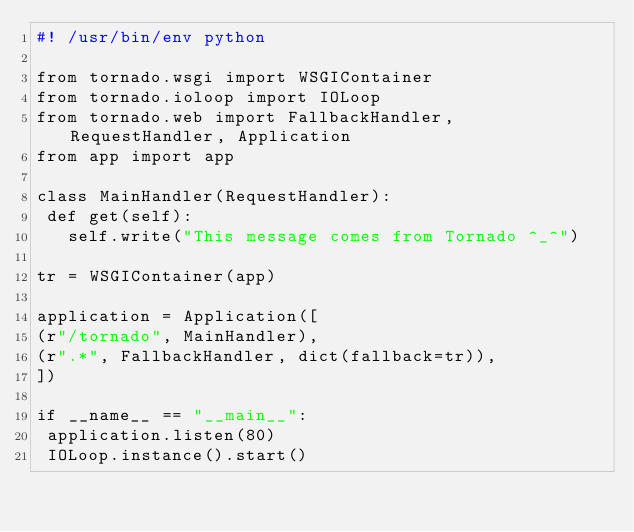Convert code to text. <code><loc_0><loc_0><loc_500><loc_500><_Python_>#! /usr/bin/env python

from tornado.wsgi import WSGIContainer
from tornado.ioloop import IOLoop
from tornado.web import FallbackHandler, RequestHandler, Application
from app import app

class MainHandler(RequestHandler):
 def get(self):
   self.write("This message comes from Tornado ^_^")

tr = WSGIContainer(app)

application = Application([
(r"/tornado", MainHandler),
(r".*", FallbackHandler, dict(fallback=tr)),
])

if __name__ == "__main__":
 application.listen(80)
 IOLoop.instance().start()
</code> 